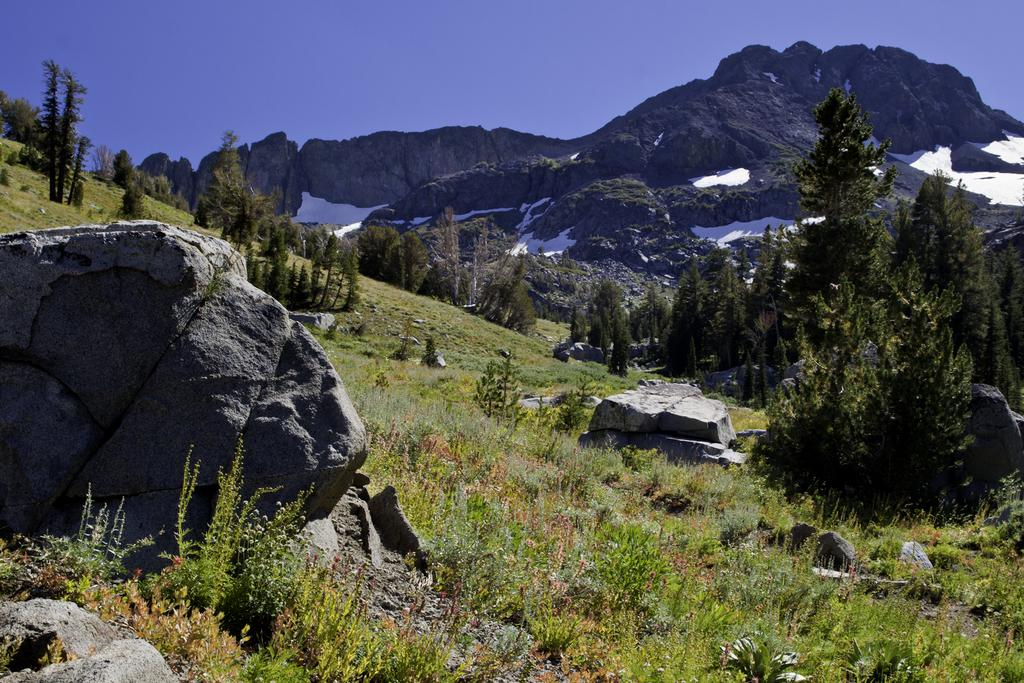What type of natural elements can be seen in the image? There are stones, grass, trees, snow, and mountains visible in the image. What type of vegetation is present in the image? There is grass and trees present in the image. What is the weather like in the image? The presence of snow suggests that it is cold or snowy in the image. What is visible in the background of the image? The sky is visible in the background of the image. What type of pet can be seen playing with a fire in the image? There is no pet or fire present in the image. What month is it in the image? The month cannot be determined from the image alone, as there is no specific information about the time of year. 